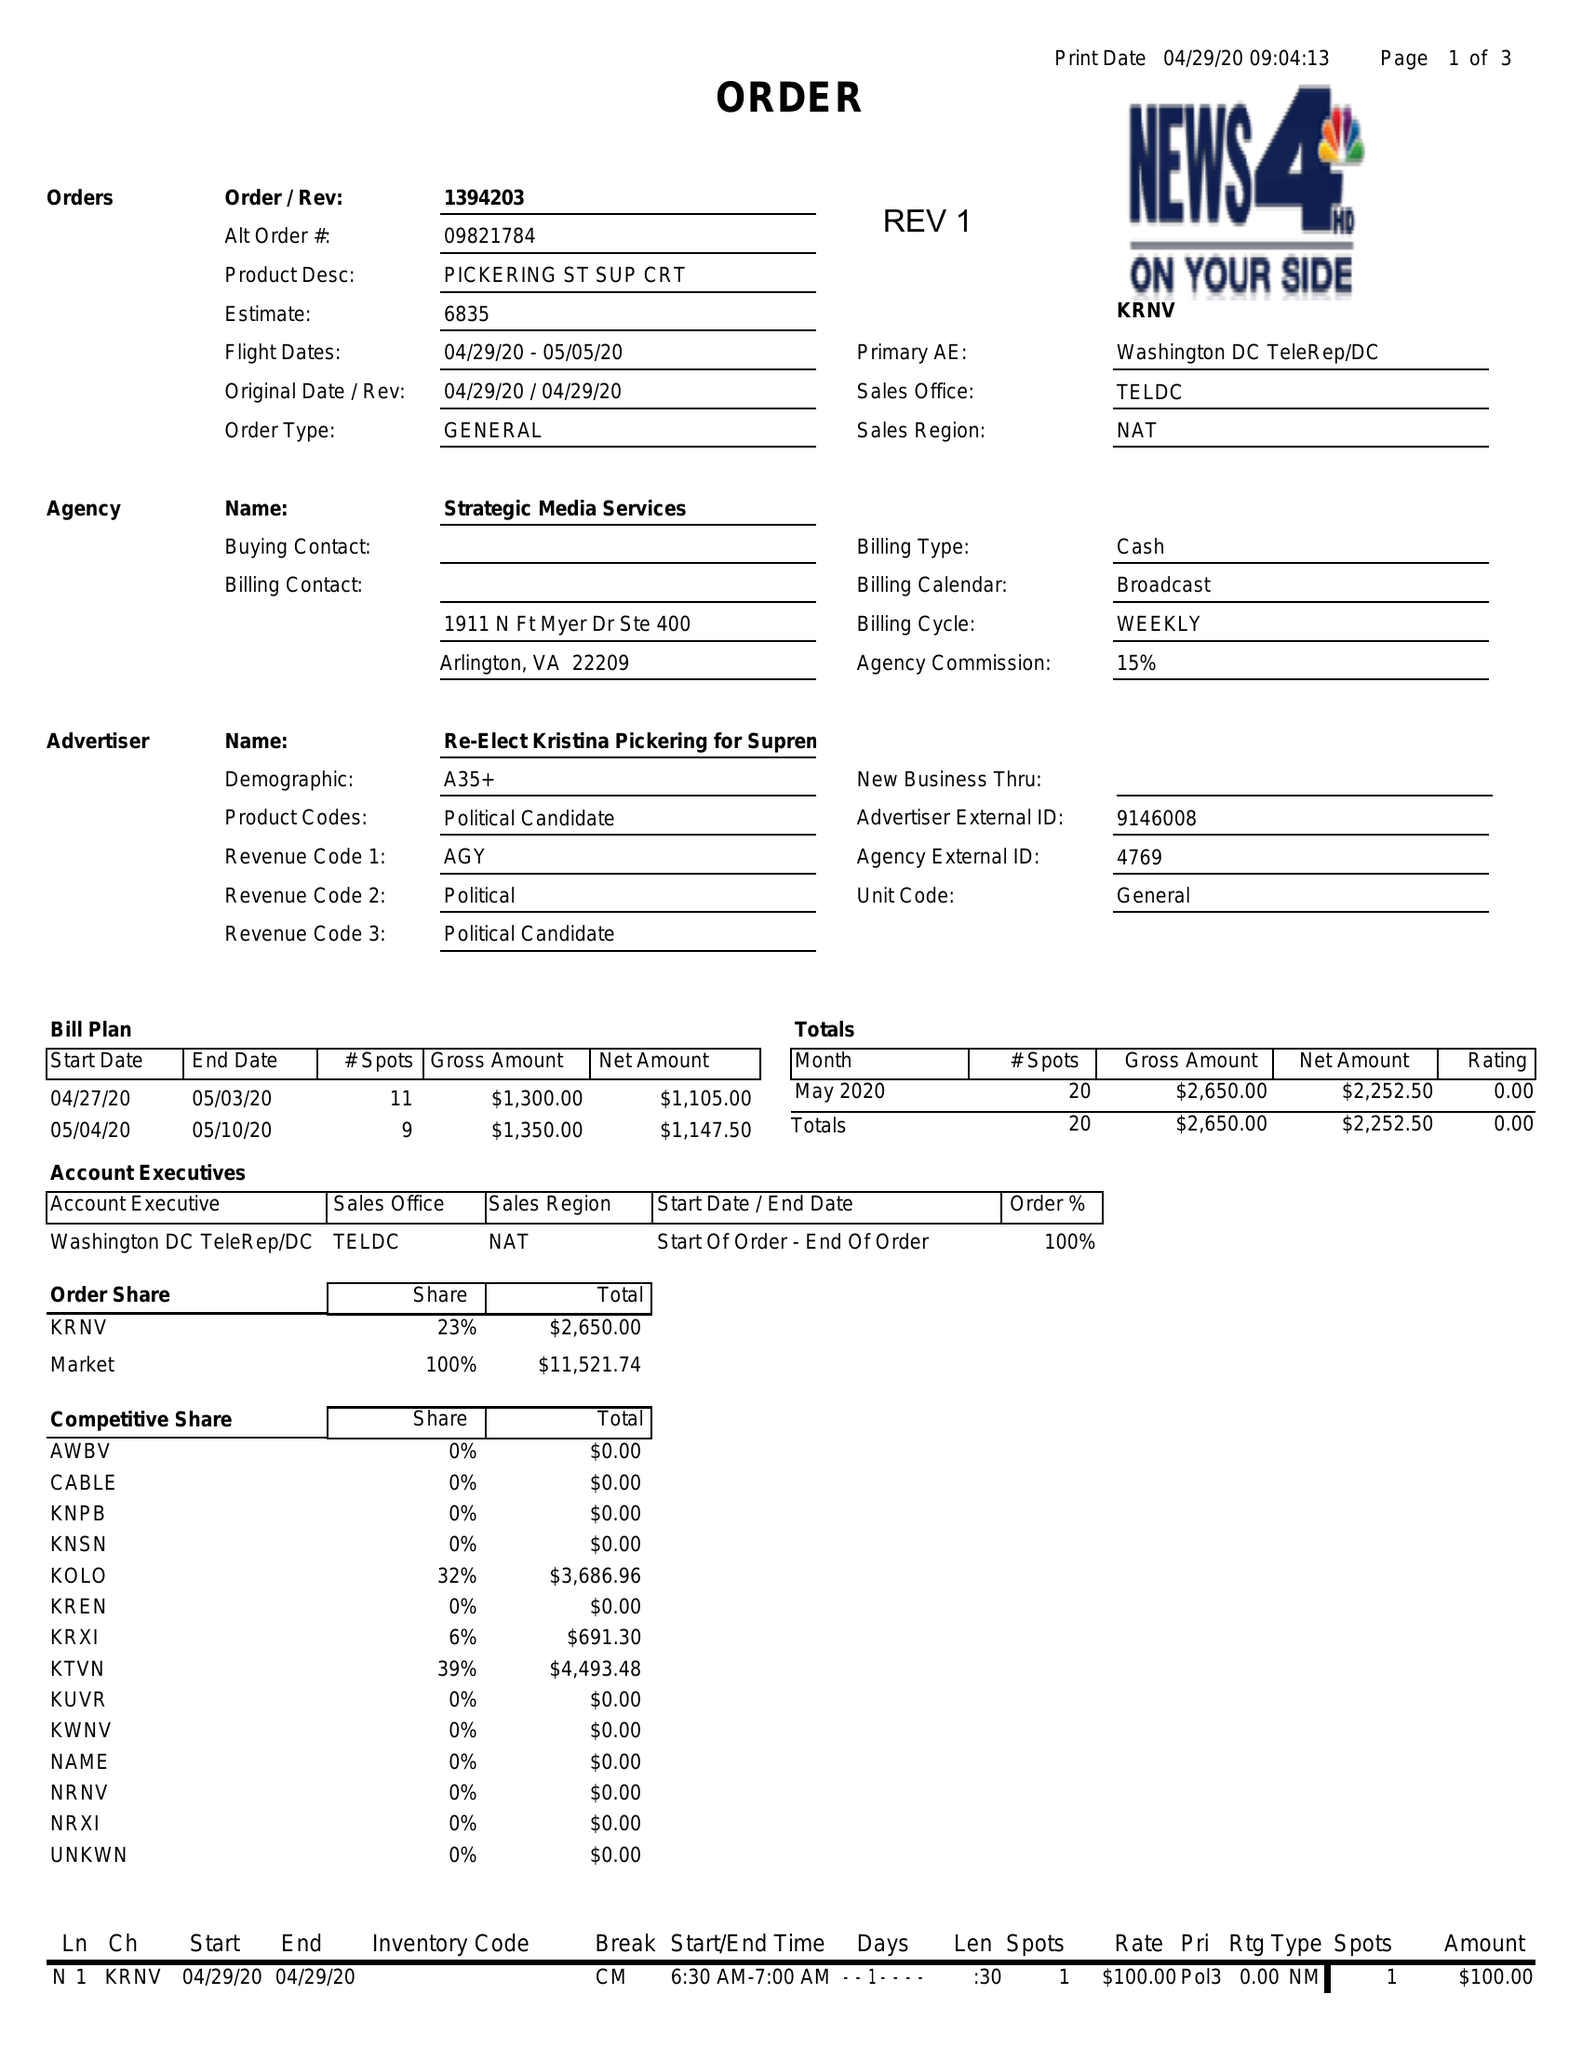What is the value for the flight_from?
Answer the question using a single word or phrase. 04/29/20 